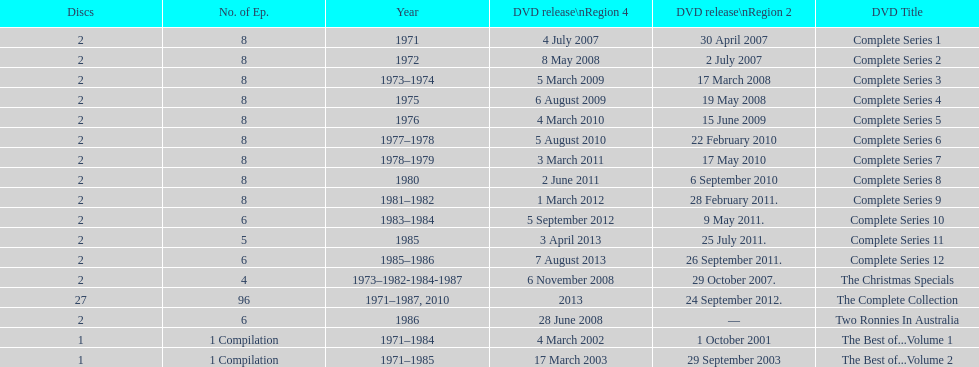What is previous to complete series 10? Complete Series 9. 